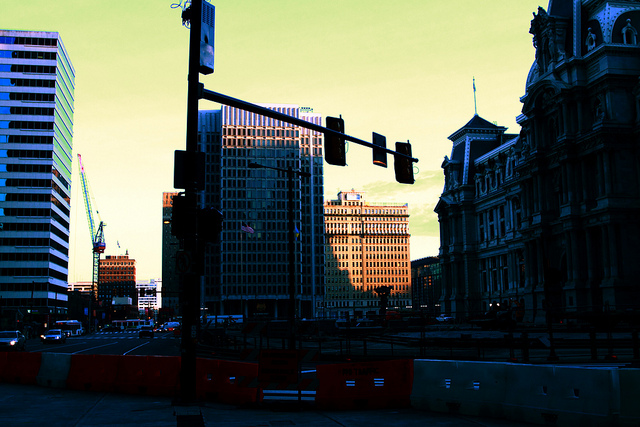What architectural styles are evident in the buildings shown in the image? The architecture in this downtown area showcases a blend of historic and modern styles. The building on the left exemplifies a modern glass facade typical of contemporary office buildings, reflecting the newer developments in urban centers. On the other hand, the elaborate and ornate building on the right with distinct statuary and detailed moldings hints at a more classical or Baroque influence, indicative of the city's historical layers and architectural evolution. 